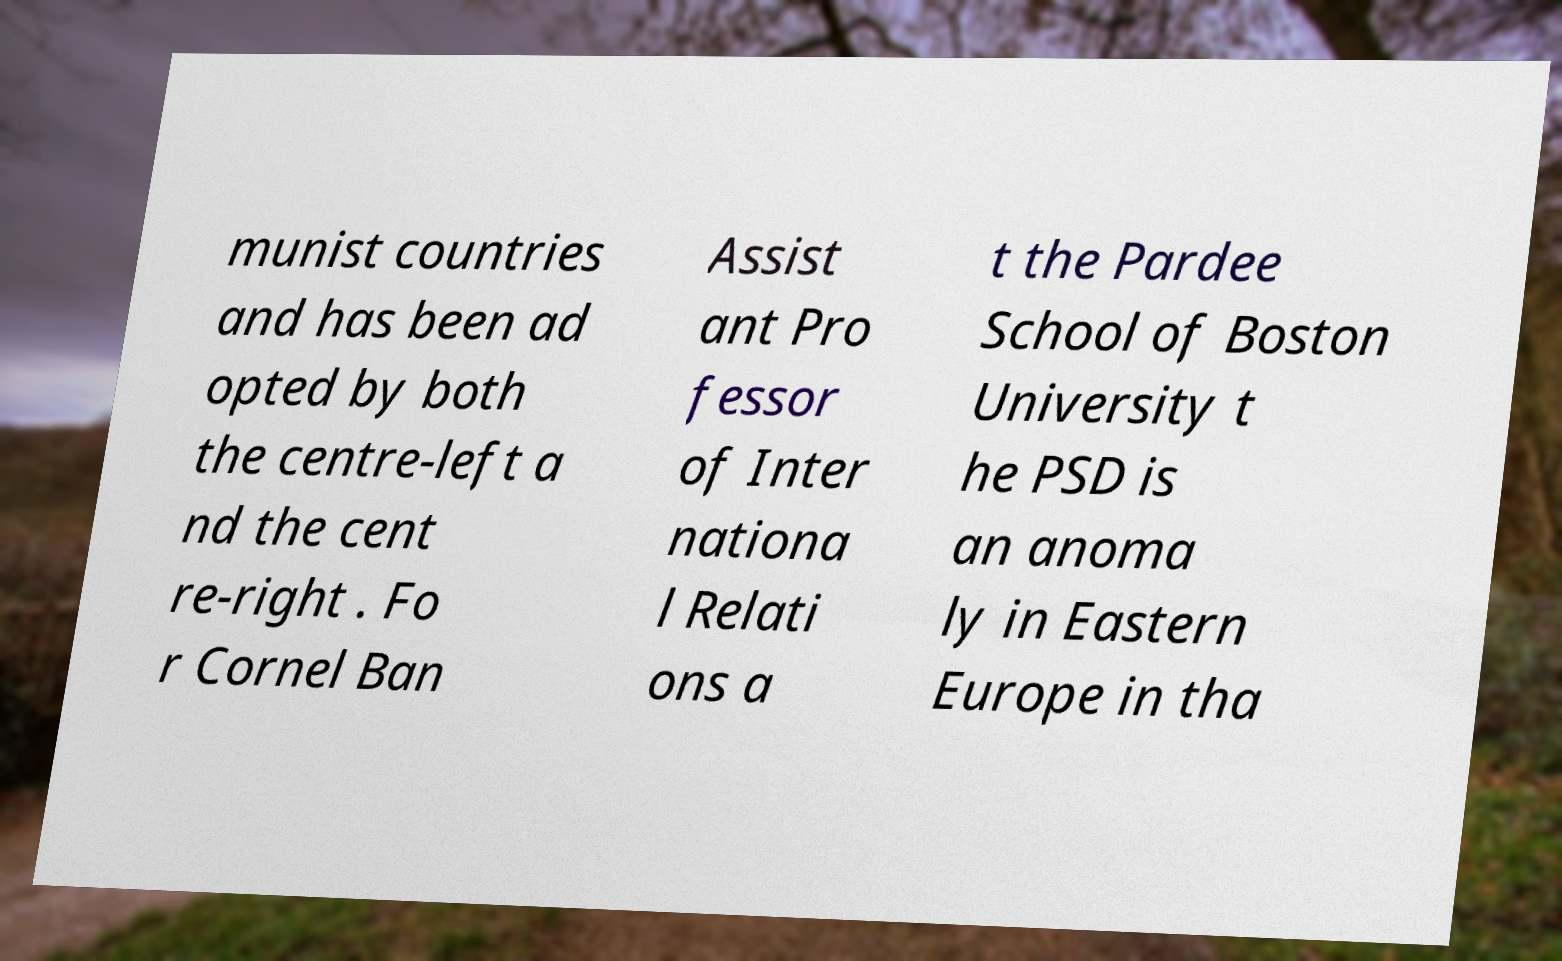Please read and relay the text visible in this image. What does it say? munist countries and has been ad opted by both the centre-left a nd the cent re-right . Fo r Cornel Ban Assist ant Pro fessor of Inter nationa l Relati ons a t the Pardee School of Boston University t he PSD is an anoma ly in Eastern Europe in tha 